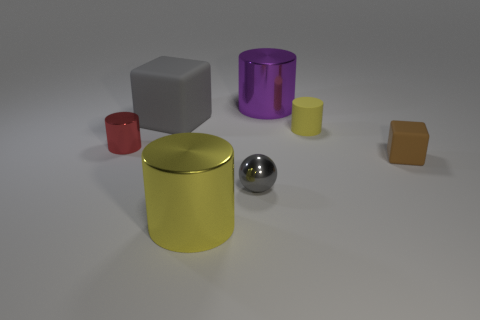Subtract all cylinders. How many objects are left? 3 Subtract 1 balls. How many balls are left? 0 Subtract all yellow cylinders. Subtract all gray spheres. How many cylinders are left? 2 Subtract all purple cylinders. How many yellow cubes are left? 0 Subtract all small yellow rubber cylinders. Subtract all brown matte cubes. How many objects are left? 5 Add 1 small spheres. How many small spheres are left? 2 Add 6 brown cubes. How many brown cubes exist? 7 Add 3 big purple objects. How many objects exist? 10 Subtract all yellow cylinders. How many cylinders are left? 2 Subtract all purple shiny cylinders. How many cylinders are left? 3 